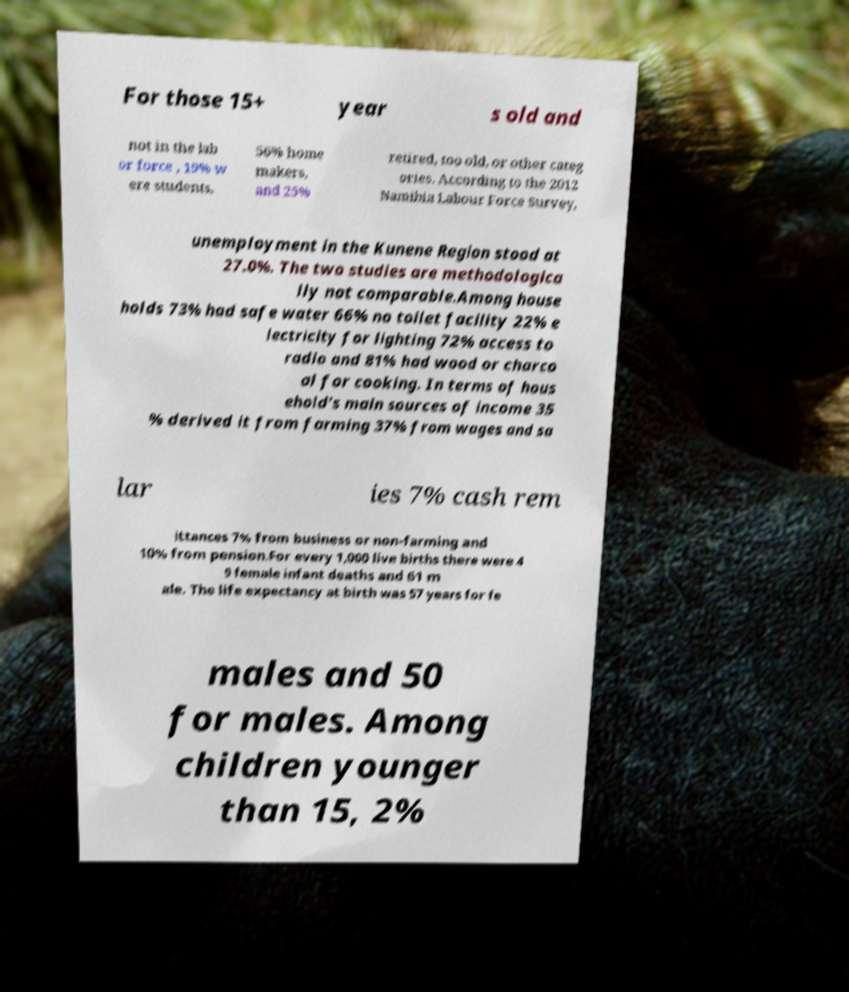Can you accurately transcribe the text from the provided image for me? For those 15+ year s old and not in the lab or force , 19% w ere students, 56% home makers, and 25% retired, too old, or other categ ories. According to the 2012 Namibia Labour Force Survey, unemployment in the Kunene Region stood at 27.0%. The two studies are methodologica lly not comparable.Among house holds 73% had safe water 66% no toilet facility 22% e lectricity for lighting 72% access to radio and 81% had wood or charco al for cooking. In terms of hous ehold's main sources of income 35 % derived it from farming 37% from wages and sa lar ies 7% cash rem ittances 7% from business or non-farming and 10% from pension.For every 1,000 live births there were 4 9 female infant deaths and 61 m ale. The life expectancy at birth was 57 years for fe males and 50 for males. Among children younger than 15, 2% 